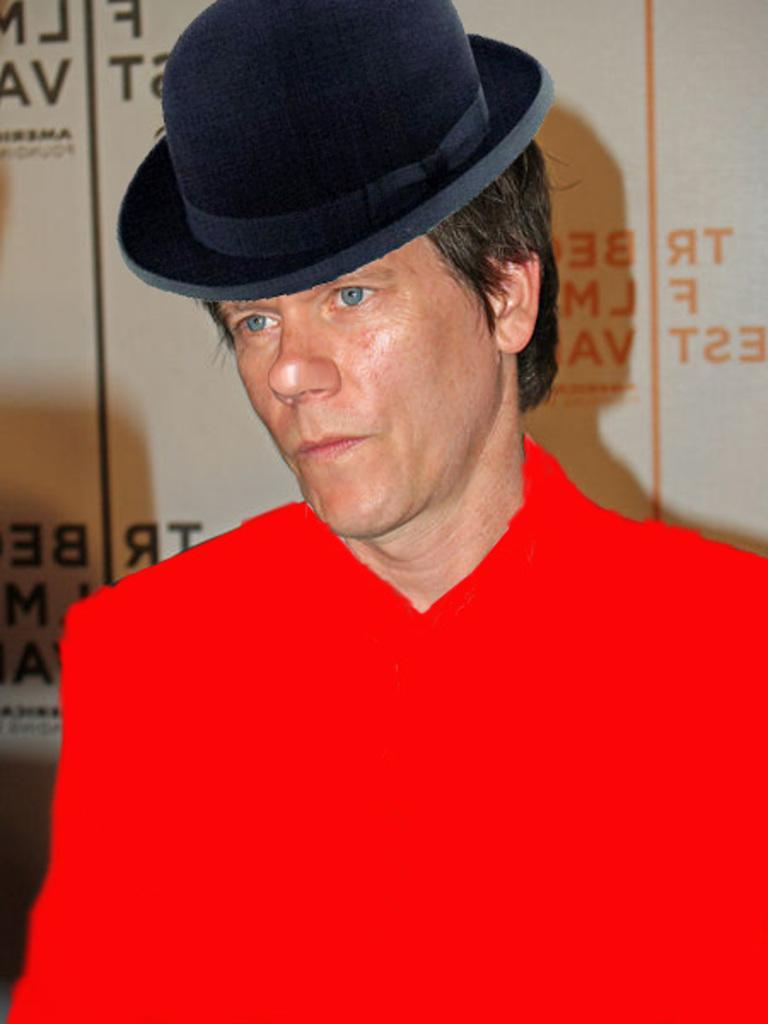Who or what is the main subject of the image? There is a person in the image. What is the person wearing? The person is wearing a red dress and a hat. Can you describe anything in the background of the image? There is text or writing visible in the background of the image. How much honey is on the person's wrist in the image? There is no honey visible on the person's wrist in the image. What type of cakes are being served in the image? There are no cakes present in the image. 